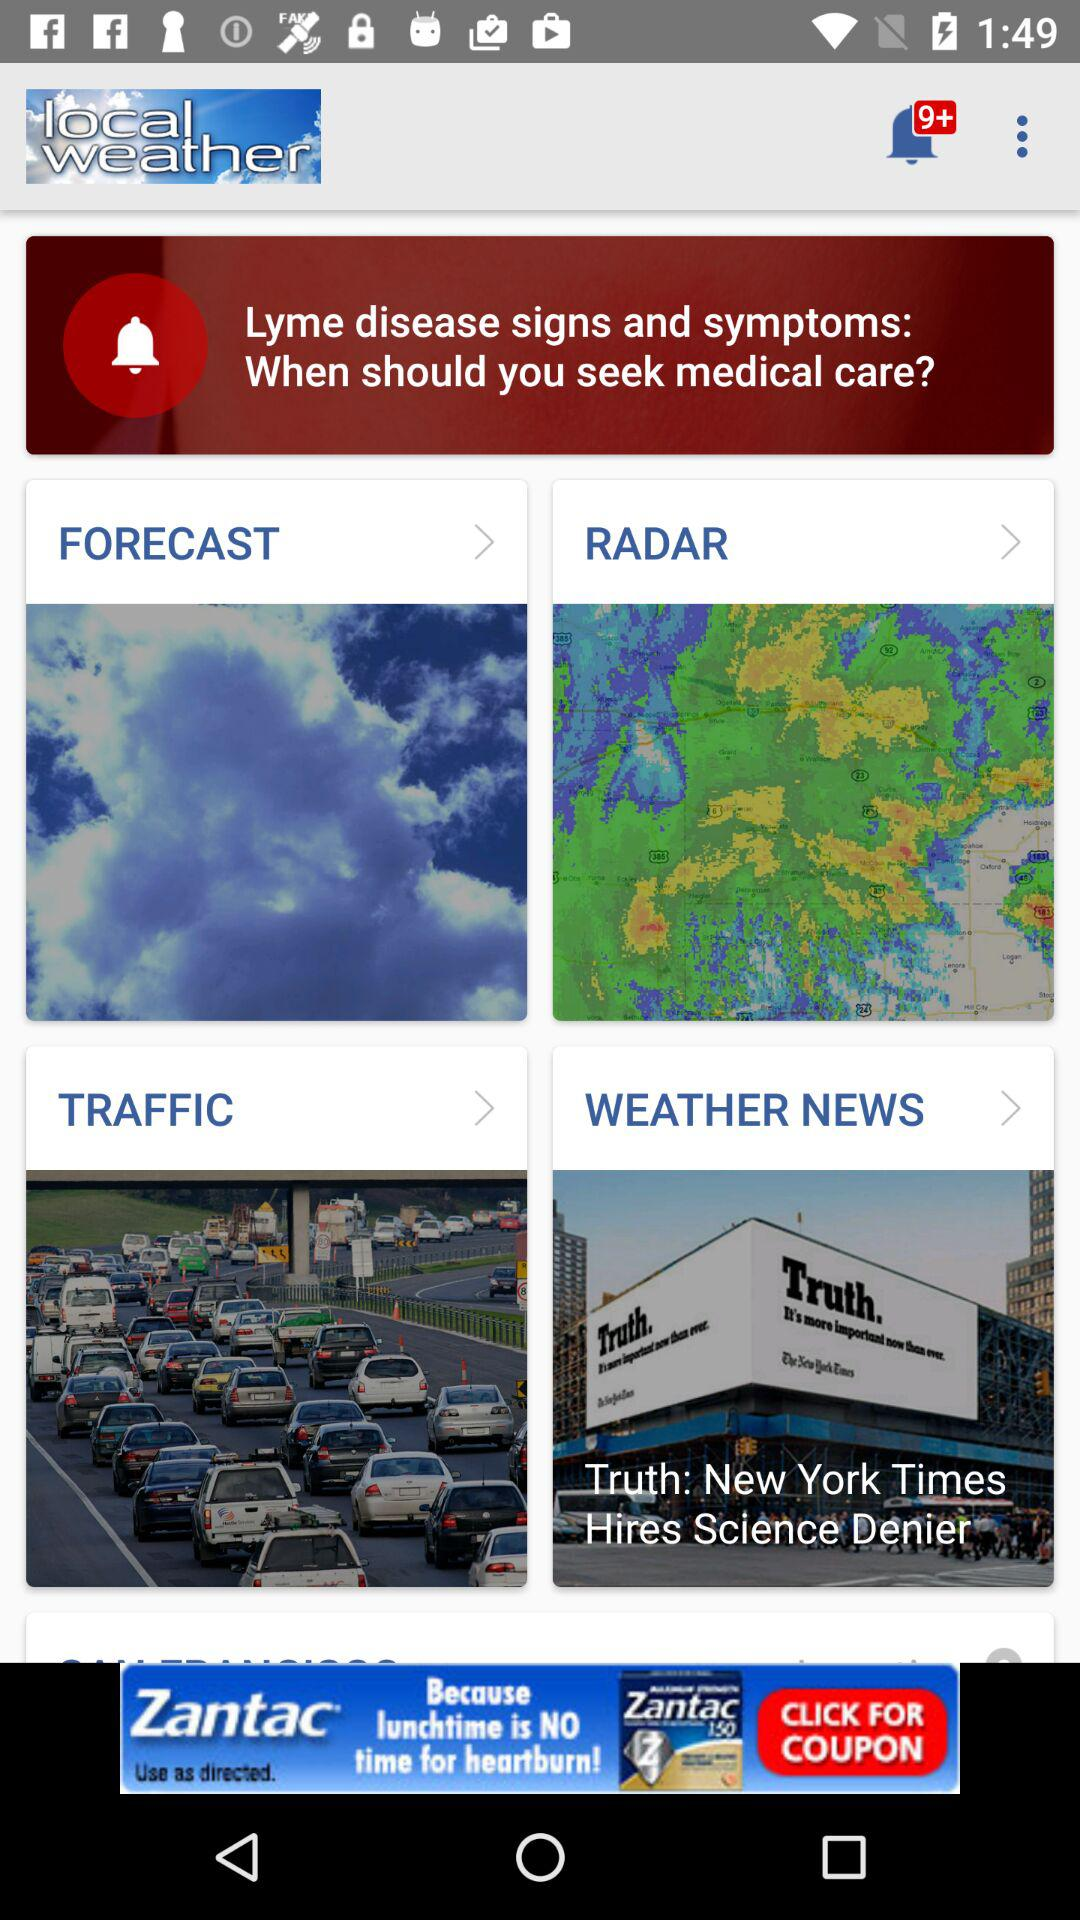How many unread notifications are shown on the screen? There are more than 9 unread notifications shown on the screen. 